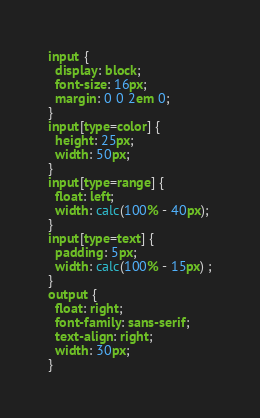Convert code to text. <code><loc_0><loc_0><loc_500><loc_500><_CSS_>input {
  display: block;
  font-size: 16px;
  margin: 0 0 2em 0;
}
input[type=color] {
  height: 25px;
  width: 50px;
}
input[type=range] {
  float: left;
  width: calc(100% - 40px);
}
input[type=text] {
  padding: 5px;
  width: calc(100% - 15px) ;
}
output {
  float: right;
  font-family: sans-serif;
  text-align: right;
  width: 30px;
}</code> 